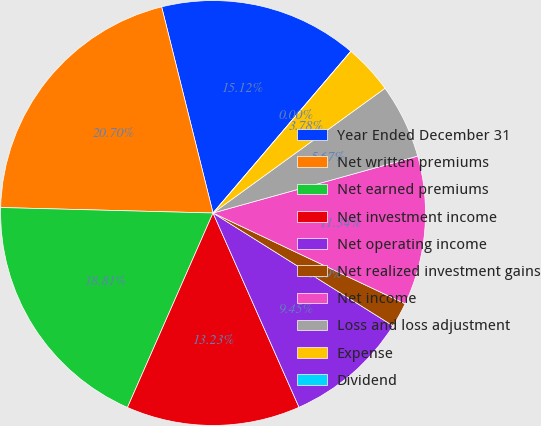<chart> <loc_0><loc_0><loc_500><loc_500><pie_chart><fcel>Year Ended December 31<fcel>Net written premiums<fcel>Net earned premiums<fcel>Net investment income<fcel>Net operating income<fcel>Net realized investment gains<fcel>Net income<fcel>Loss and loss adjustment<fcel>Expense<fcel>Dividend<nl><fcel>15.12%<fcel>20.7%<fcel>18.81%<fcel>13.23%<fcel>9.45%<fcel>1.89%<fcel>11.34%<fcel>5.67%<fcel>3.78%<fcel>0.0%<nl></chart> 